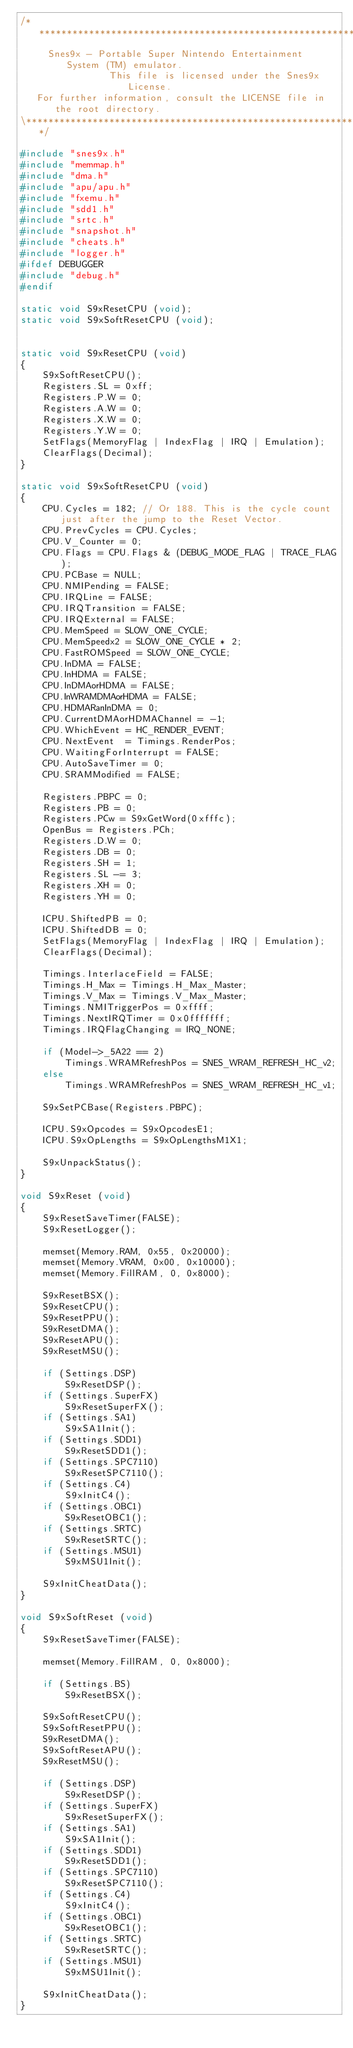Convert code to text. <code><loc_0><loc_0><loc_500><loc_500><_C++_>/*****************************************************************************\
     Snes9x - Portable Super Nintendo Entertainment System (TM) emulator.
                This file is licensed under the Snes9x License.
   For further information, consult the LICENSE file in the root directory.
\*****************************************************************************/

#include "snes9x.h"
#include "memmap.h"
#include "dma.h"
#include "apu/apu.h"
#include "fxemu.h"
#include "sdd1.h"
#include "srtc.h"
#include "snapshot.h"
#include "cheats.h"
#include "logger.h"
#ifdef DEBUGGER
#include "debug.h"
#endif

static void S9xResetCPU (void);
static void S9xSoftResetCPU (void);


static void S9xResetCPU (void)
{
	S9xSoftResetCPU();
	Registers.SL = 0xff;
	Registers.P.W = 0;
	Registers.A.W = 0;
	Registers.X.W = 0;
	Registers.Y.W = 0;
	SetFlags(MemoryFlag | IndexFlag | IRQ | Emulation);
	ClearFlags(Decimal);
}

static void S9xSoftResetCPU (void)
{
	CPU.Cycles = 182; // Or 188. This is the cycle count just after the jump to the Reset Vector.
	CPU.PrevCycles = CPU.Cycles;
	CPU.V_Counter = 0;
	CPU.Flags = CPU.Flags & (DEBUG_MODE_FLAG | TRACE_FLAG);
	CPU.PCBase = NULL;
	CPU.NMIPending = FALSE;
	CPU.IRQLine = FALSE;
	CPU.IRQTransition = FALSE;
	CPU.IRQExternal = FALSE;
	CPU.MemSpeed = SLOW_ONE_CYCLE;
	CPU.MemSpeedx2 = SLOW_ONE_CYCLE * 2;
	CPU.FastROMSpeed = SLOW_ONE_CYCLE;
	CPU.InDMA = FALSE;
	CPU.InHDMA = FALSE;
	CPU.InDMAorHDMA = FALSE;
	CPU.InWRAMDMAorHDMA = FALSE;
	CPU.HDMARanInDMA = 0;
	CPU.CurrentDMAorHDMAChannel = -1;
	CPU.WhichEvent = HC_RENDER_EVENT;
	CPU.NextEvent  = Timings.RenderPos;
	CPU.WaitingForInterrupt = FALSE;
	CPU.AutoSaveTimer = 0;
	CPU.SRAMModified = FALSE;

	Registers.PBPC = 0;
	Registers.PB = 0;
	Registers.PCw = S9xGetWord(0xfffc);
	OpenBus = Registers.PCh;
	Registers.D.W = 0;
	Registers.DB = 0;
	Registers.SH = 1;
	Registers.SL -= 3;
	Registers.XH = 0;
	Registers.YH = 0;

	ICPU.ShiftedPB = 0;
	ICPU.ShiftedDB = 0;
	SetFlags(MemoryFlag | IndexFlag | IRQ | Emulation);
	ClearFlags(Decimal);

	Timings.InterlaceField = FALSE;
	Timings.H_Max = Timings.H_Max_Master;
	Timings.V_Max = Timings.V_Max_Master;
	Timings.NMITriggerPos = 0xffff;
	Timings.NextIRQTimer = 0x0fffffff;
	Timings.IRQFlagChanging = IRQ_NONE;

	if (Model->_5A22 == 2)
		Timings.WRAMRefreshPos = SNES_WRAM_REFRESH_HC_v2;
	else
		Timings.WRAMRefreshPos = SNES_WRAM_REFRESH_HC_v1;

	S9xSetPCBase(Registers.PBPC);

	ICPU.S9xOpcodes = S9xOpcodesE1;
	ICPU.S9xOpLengths = S9xOpLengthsM1X1;

	S9xUnpackStatus();
}

void S9xReset (void)
{
	S9xResetSaveTimer(FALSE);
	S9xResetLogger();

	memset(Memory.RAM, 0x55, 0x20000);
	memset(Memory.VRAM, 0x00, 0x10000);
	memset(Memory.FillRAM, 0, 0x8000);

	S9xResetBSX();
	S9xResetCPU();
	S9xResetPPU();
	S9xResetDMA();
	S9xResetAPU();
    S9xResetMSU();

	if (Settings.DSP)
		S9xResetDSP();
	if (Settings.SuperFX)
		S9xResetSuperFX();
	if (Settings.SA1)
		S9xSA1Init();
	if (Settings.SDD1)
		S9xResetSDD1();
	if (Settings.SPC7110)
		S9xResetSPC7110();
	if (Settings.C4)
		S9xInitC4();
	if (Settings.OBC1)
		S9xResetOBC1();
	if (Settings.SRTC)
		S9xResetSRTC();
	if (Settings.MSU1)
		S9xMSU1Init();

	S9xInitCheatData();
}

void S9xSoftReset (void)
{
	S9xResetSaveTimer(FALSE);

	memset(Memory.FillRAM, 0, 0x8000);

	if (Settings.BS)
		S9xResetBSX();

	S9xSoftResetCPU();
	S9xSoftResetPPU();
	S9xResetDMA();
	S9xSoftResetAPU();
    S9xResetMSU();

	if (Settings.DSP)
		S9xResetDSP();
	if (Settings.SuperFX)
		S9xResetSuperFX();
	if (Settings.SA1)
		S9xSA1Init();
	if (Settings.SDD1)
		S9xResetSDD1();
	if (Settings.SPC7110)
		S9xResetSPC7110();
	if (Settings.C4)
		S9xInitC4();
	if (Settings.OBC1)
		S9xResetOBC1();
	if (Settings.SRTC)
		S9xResetSRTC();
	if (Settings.MSU1)
		S9xMSU1Init();

	S9xInitCheatData();
}
</code> 